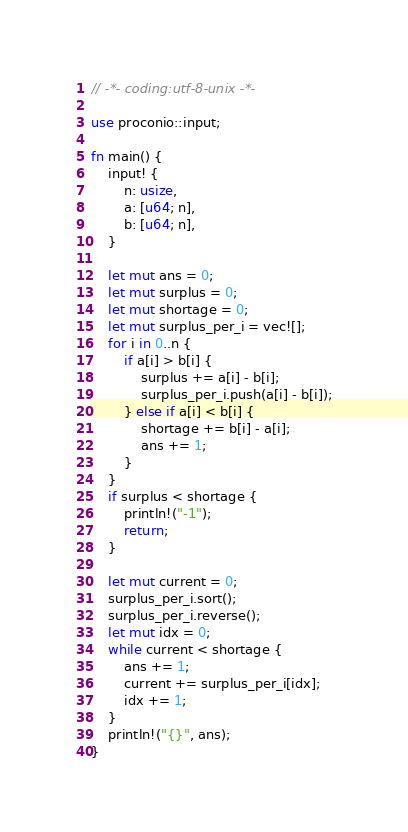<code> <loc_0><loc_0><loc_500><loc_500><_Rust_>// -*- coding:utf-8-unix -*-

use proconio::input;

fn main() {
    input! {
        n: usize,
        a: [u64; n],
        b: [u64; n],
    }

    let mut ans = 0;
    let mut surplus = 0;
    let mut shortage = 0;
    let mut surplus_per_i = vec![];
    for i in 0..n {
        if a[i] > b[i] {
            surplus += a[i] - b[i];
            surplus_per_i.push(a[i] - b[i]);
        } else if a[i] < b[i] {
            shortage += b[i] - a[i];
            ans += 1;
        }
    }
    if surplus < shortage {
        println!("-1");
        return;
    }

    let mut current = 0;
    surplus_per_i.sort();
    surplus_per_i.reverse();
    let mut idx = 0;
    while current < shortage {
        ans += 1;
        current += surplus_per_i[idx];
        idx += 1;
    }
    println!("{}", ans);
}
</code> 